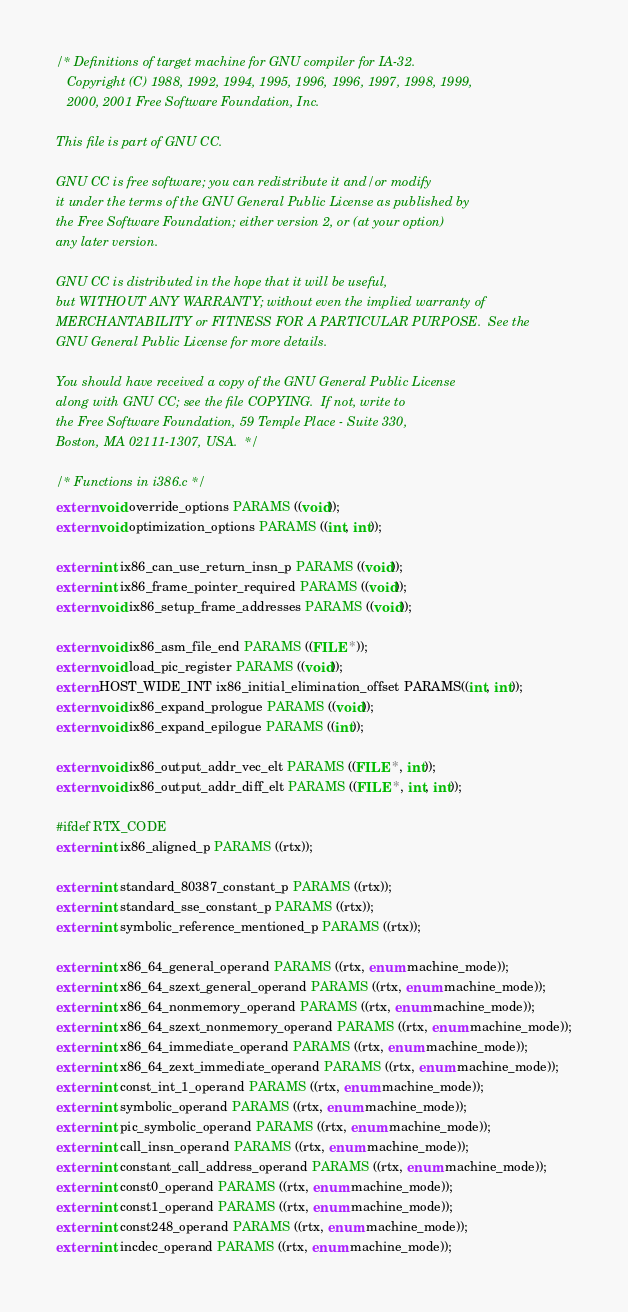<code> <loc_0><loc_0><loc_500><loc_500><_C_>/* Definitions of target machine for GNU compiler for IA-32.
   Copyright (C) 1988, 1992, 1994, 1995, 1996, 1996, 1997, 1998, 1999,
   2000, 2001 Free Software Foundation, Inc.

This file is part of GNU CC.

GNU CC is free software; you can redistribute it and/or modify
it under the terms of the GNU General Public License as published by
the Free Software Foundation; either version 2, or (at your option)
any later version.

GNU CC is distributed in the hope that it will be useful,
but WITHOUT ANY WARRANTY; without even the implied warranty of
MERCHANTABILITY or FITNESS FOR A PARTICULAR PURPOSE.  See the
GNU General Public License for more details.

You should have received a copy of the GNU General Public License
along with GNU CC; see the file COPYING.  If not, write to
the Free Software Foundation, 59 Temple Place - Suite 330,
Boston, MA 02111-1307, USA.  */

/* Functions in i386.c */
extern void override_options PARAMS ((void));
extern void optimization_options PARAMS ((int, int));

extern int ix86_can_use_return_insn_p PARAMS ((void));
extern int ix86_frame_pointer_required PARAMS ((void));
extern void ix86_setup_frame_addresses PARAMS ((void));

extern void ix86_asm_file_end PARAMS ((FILE *));
extern void load_pic_register PARAMS ((void));
extern HOST_WIDE_INT ix86_initial_elimination_offset PARAMS((int, int));
extern void ix86_expand_prologue PARAMS ((void));
extern void ix86_expand_epilogue PARAMS ((int));

extern void ix86_output_addr_vec_elt PARAMS ((FILE *, int));
extern void ix86_output_addr_diff_elt PARAMS ((FILE *, int, int));

#ifdef RTX_CODE
extern int ix86_aligned_p PARAMS ((rtx));

extern int standard_80387_constant_p PARAMS ((rtx));
extern int standard_sse_constant_p PARAMS ((rtx));
extern int symbolic_reference_mentioned_p PARAMS ((rtx));

extern int x86_64_general_operand PARAMS ((rtx, enum machine_mode));
extern int x86_64_szext_general_operand PARAMS ((rtx, enum machine_mode));
extern int x86_64_nonmemory_operand PARAMS ((rtx, enum machine_mode));
extern int x86_64_szext_nonmemory_operand PARAMS ((rtx, enum machine_mode));
extern int x86_64_immediate_operand PARAMS ((rtx, enum machine_mode));
extern int x86_64_zext_immediate_operand PARAMS ((rtx, enum machine_mode));
extern int const_int_1_operand PARAMS ((rtx, enum machine_mode));
extern int symbolic_operand PARAMS ((rtx, enum machine_mode));
extern int pic_symbolic_operand PARAMS ((rtx, enum machine_mode));
extern int call_insn_operand PARAMS ((rtx, enum machine_mode));
extern int constant_call_address_operand PARAMS ((rtx, enum machine_mode));
extern int const0_operand PARAMS ((rtx, enum machine_mode));
extern int const1_operand PARAMS ((rtx, enum machine_mode));
extern int const248_operand PARAMS ((rtx, enum machine_mode));
extern int incdec_operand PARAMS ((rtx, enum machine_mode));</code> 